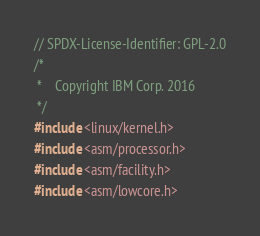Convert code to text. <code><loc_0><loc_0><loc_500><loc_500><_C_>// SPDX-License-Identifier: GPL-2.0
/*
 *    Copyright IBM Corp. 2016
 */
#include <linux/kernel.h>
#include <asm/processor.h>
#include <asm/facility.h>
#include <asm/lowcore.h></code> 